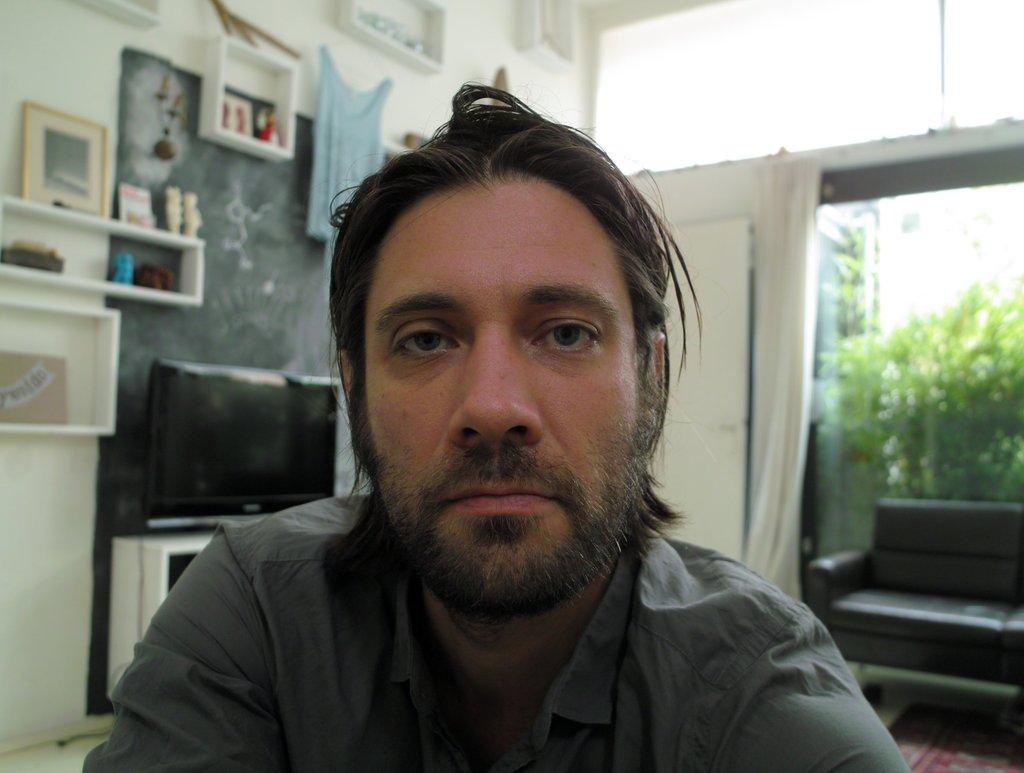What is the person in the room doing? The fact does not specify what the person is doing, so we cannot answer this question definitively. What type of object is in the room that typically holds pictures or artwork? There is a frame in the room. What type of material is present in the room that can be used for covering or decorating? There is a cloth in the room. What type of electronic device is in the room for entertainment purposes? There is a TV in the room. What type of furniture is in the room for seating purposes? There is a sofa in the room. What type of opening is in the room that allows natural light to enter? There is a window in the room. What type of window treatment is present in the room? There is a curtain associated with the window. What type of vegetation can be seen through the window? Plants are visible through the window. What type of alarm can be heard going off in the room? There is no mention of an alarm in the provided facts, so we cannot answer this question definitively. 